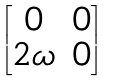<formula> <loc_0><loc_0><loc_500><loc_500>\begin{bmatrix} 0 & 0 \\ 2 \omega & 0 \end{bmatrix}</formula> 